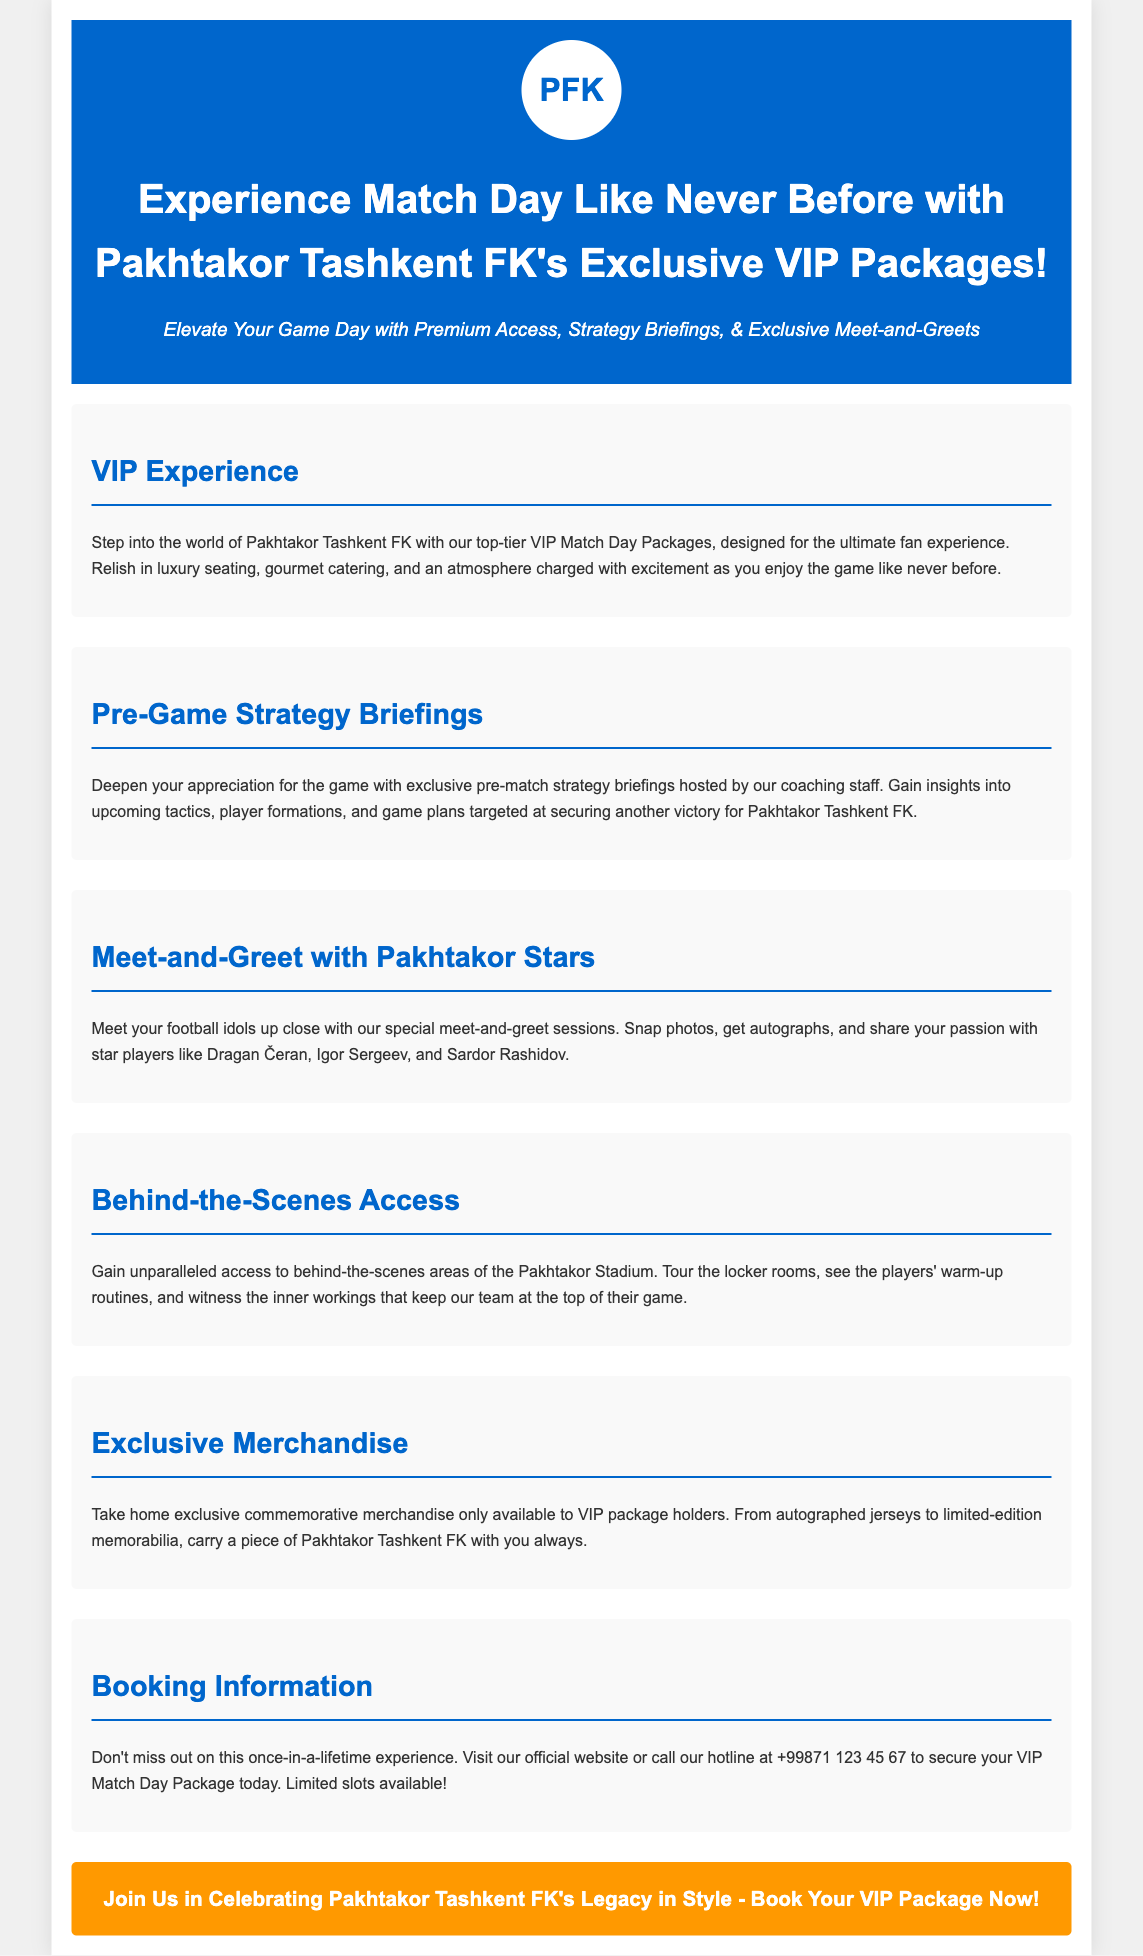What is the name of the football club featured? The document presents information about Pakhtakor Tashkent FK.
Answer: Pakhtakor Tashkent FK What does the VIP package include regarding seating? The VIP experience mentions luxury seating as part of the package.
Answer: Luxury seating Who hosts the pre-game strategy briefings? The briefings are hosted by the coaching staff of Pakhtakor Tashkent FK.
Answer: Coaching staff What type of access is provided behind the scenes? The document describes access to behind-the-scenes areas at the Pakhtakor Stadium.
Answer: Behind-the-scenes access What can VIP package holders take home? The VIP experience includes exclusive commemorative merchandise for holders.
Answer: Exclusive merchandise How can one book a VIP Match Day Package? Booking can be done through the official website or a hotline provided in the document.
Answer: Official website or hotline Which player is mentioned in the meet-and-greet section? The document lists Dragan Čeran as one of the star players available for meet-and-greets.
Answer: Dragan Čeran How is the atmosphere during the game described? The atmosphere is characterized as charged with excitement.
Answer: Charged with excitement What is the contact number for booking inquiries? The document provides a hotline number for securing VIP packages.
Answer: +99871 123 45 67 